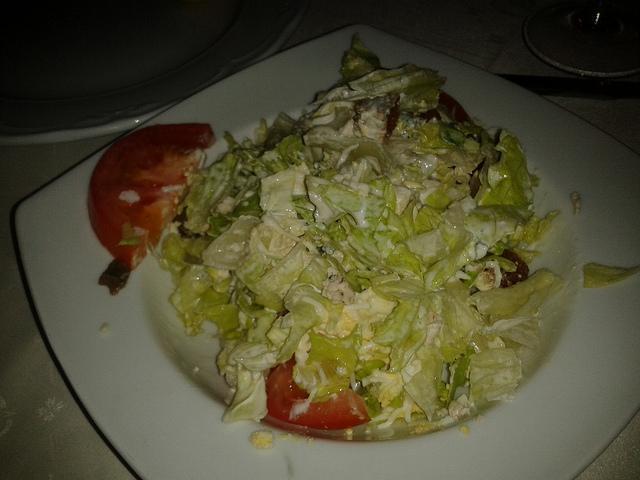How many dining tables can you see?
Give a very brief answer. 1. How many people in the shot?
Give a very brief answer. 0. 